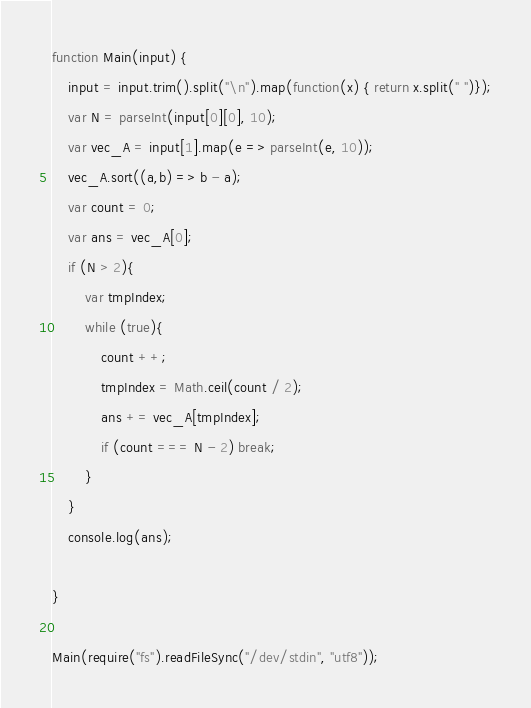Convert code to text. <code><loc_0><loc_0><loc_500><loc_500><_JavaScript_>function Main(input) {
    input = input.trim().split("\n").map(function(x) { return x.split(" ")});
    var N = parseInt(input[0][0], 10);
    var vec_A = input[1].map(e => parseInt(e, 10));
    vec_A.sort((a,b) => b - a);
    var count = 0;
    var ans = vec_A[0];
    if (N > 2){
        var tmpIndex;
        while (true){
            count ++;
            tmpIndex = Math.ceil(count / 2);
            ans += vec_A[tmpIndex];
            if (count === N - 2) break;
        }    
    }
    console.log(ans);

}

Main(require("fs").readFileSync("/dev/stdin", "utf8")); </code> 